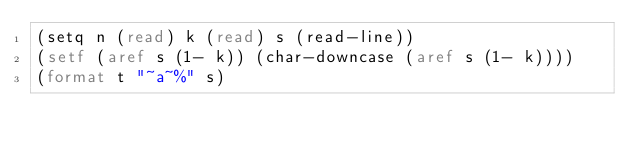<code> <loc_0><loc_0><loc_500><loc_500><_Lisp_>(setq n (read) k (read) s (read-line))
(setf (aref s (1- k)) (char-downcase (aref s (1- k))))
(format t "~a~%" s)</code> 